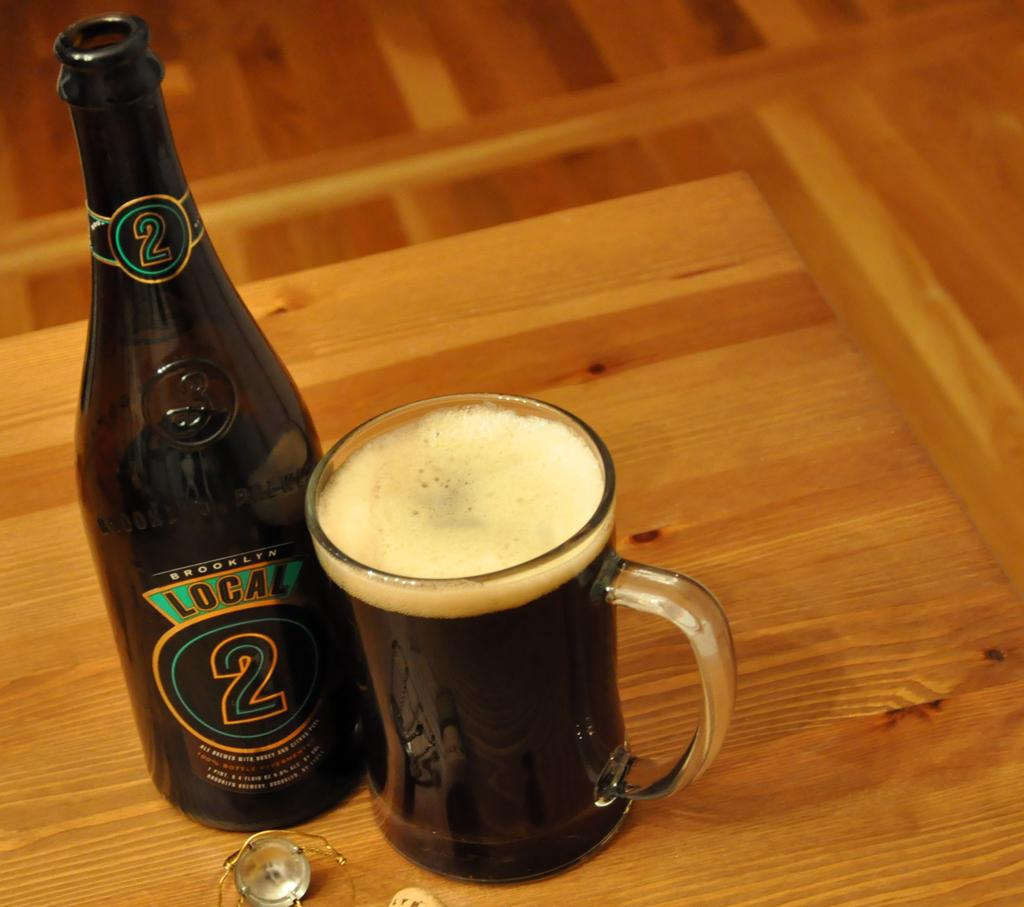<image>
Offer a succinct explanation of the picture presented. a bottle of beer with the label reading brooklyn local 2 